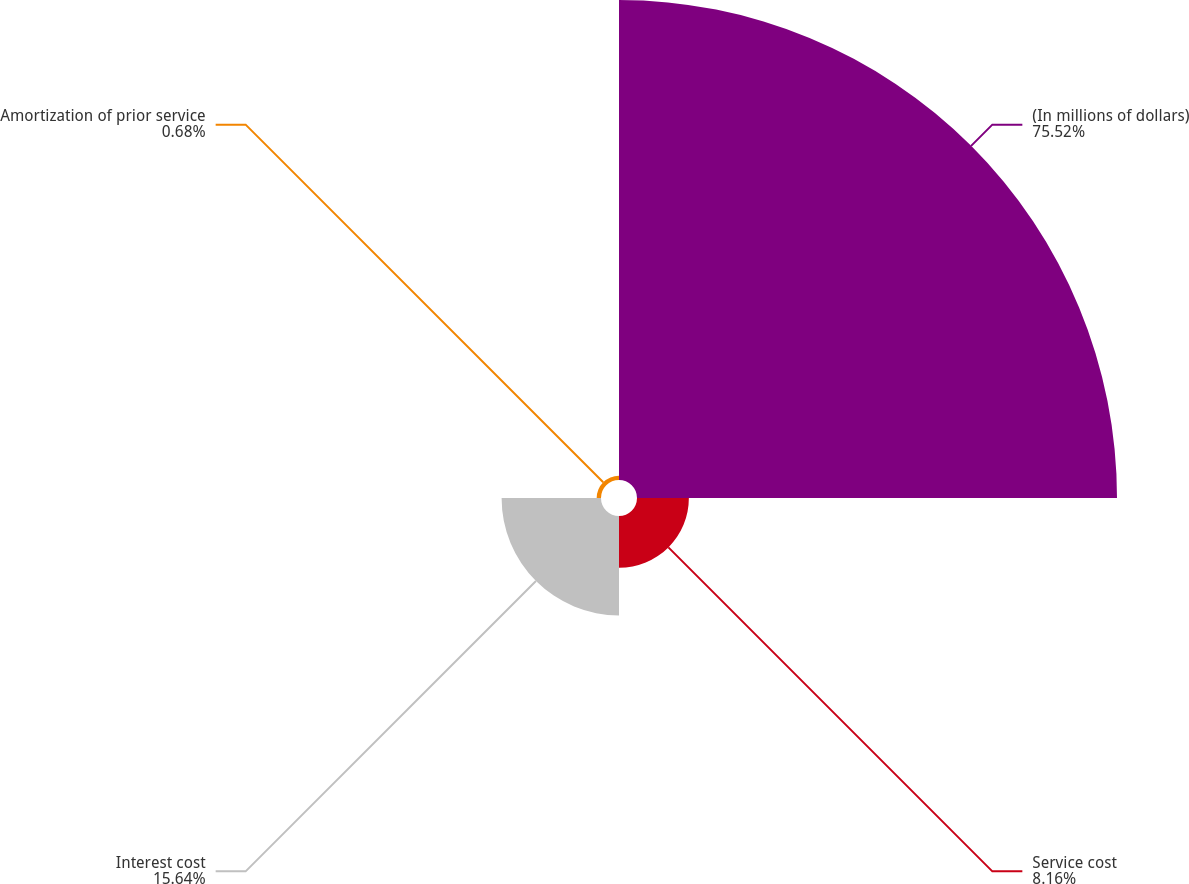Convert chart. <chart><loc_0><loc_0><loc_500><loc_500><pie_chart><fcel>(In millions of dollars)<fcel>Service cost<fcel>Interest cost<fcel>Amortization of prior service<nl><fcel>75.52%<fcel>8.16%<fcel>15.64%<fcel>0.68%<nl></chart> 